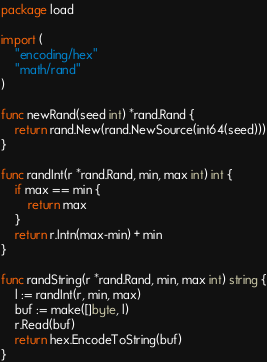Convert code to text. <code><loc_0><loc_0><loc_500><loc_500><_Go_>package load

import (
	"encoding/hex"
	"math/rand"
)

func newRand(seed int) *rand.Rand {
	return rand.New(rand.NewSource(int64(seed)))
}

func randInt(r *rand.Rand, min, max int) int {
	if max == min {
		return max
	}
	return r.Intn(max-min) + min
}

func randString(r *rand.Rand, min, max int) string {
	l := randInt(r, min, max)
	buf := make([]byte, l)
	r.Read(buf)
	return hex.EncodeToString(buf)
}
</code> 